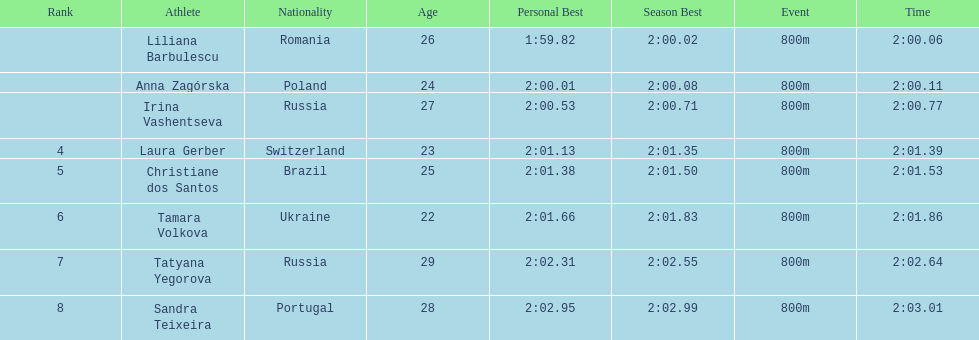In regards to anna zagorska, what was her finishing time? 2:00.11. 